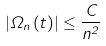Convert formula to latex. <formula><loc_0><loc_0><loc_500><loc_500>\left | \Omega _ { n } \left ( t \right ) \right | \leq \frac { C } { n ^ { 2 } }</formula> 